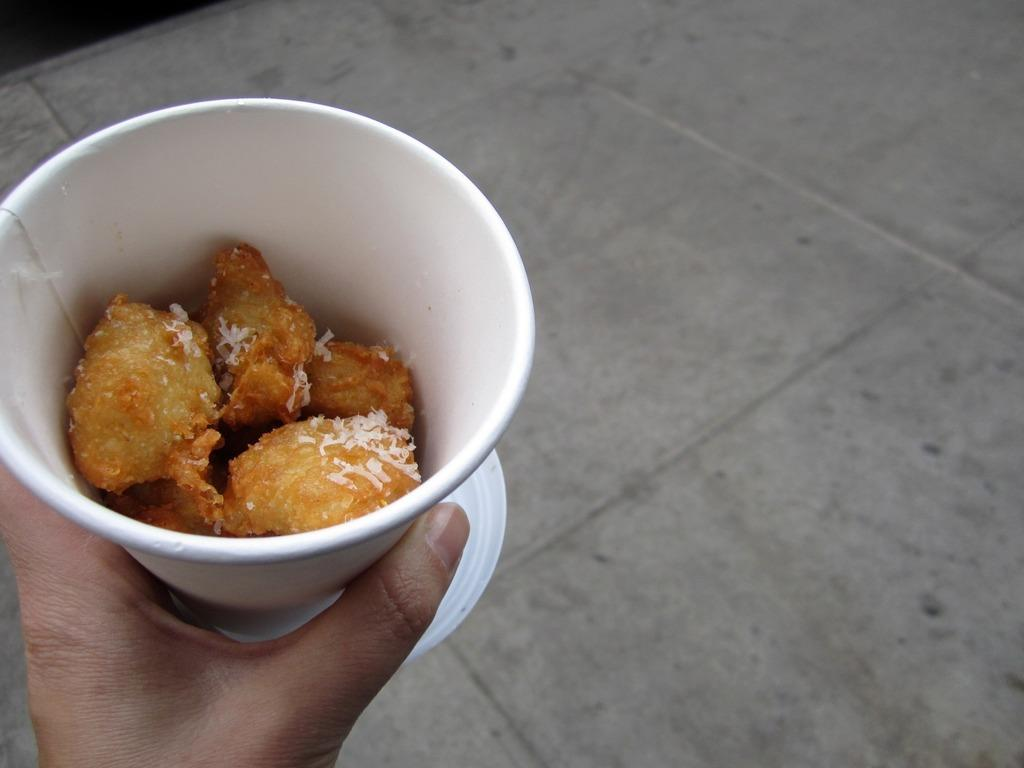What is in the bowl that is visible in the image? There is food in a bowl in the image. Who is holding the bowl in the image? There is a person holding the bowl in the image. What can be seen in the top right corner of the image? There is a floor visible in the top right corner of the image. What type of meat is being transported in the image? There is no meat or transportation present in the image. 